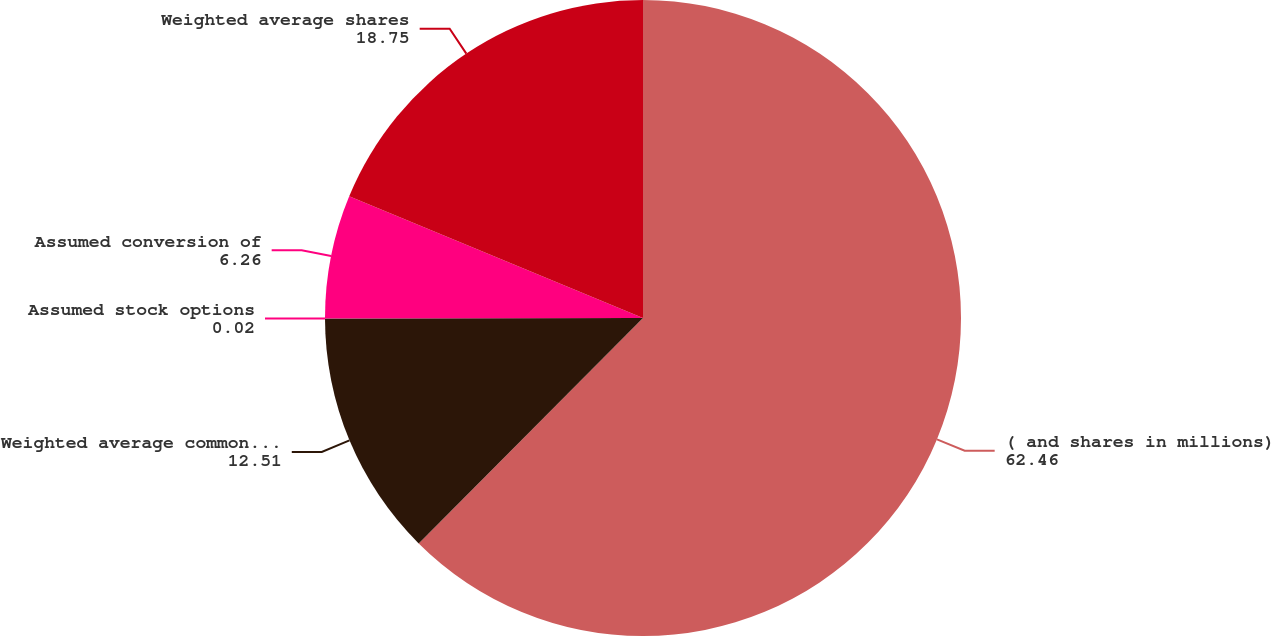Convert chart. <chart><loc_0><loc_0><loc_500><loc_500><pie_chart><fcel>( and shares in millions)<fcel>Weighted average common shares<fcel>Assumed stock options<fcel>Assumed conversion of<fcel>Weighted average shares<nl><fcel>62.46%<fcel>12.51%<fcel>0.02%<fcel>6.26%<fcel>18.75%<nl></chart> 